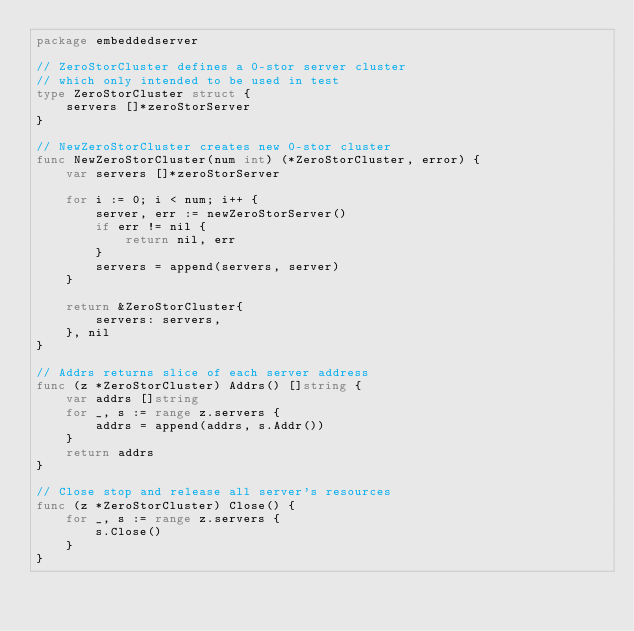<code> <loc_0><loc_0><loc_500><loc_500><_Go_>package embeddedserver

// ZeroStorCluster defines a 0-stor server cluster
// which only intended to be used in test
type ZeroStorCluster struct {
	servers []*zeroStorServer
}

// NewZeroStorCluster creates new 0-stor cluster
func NewZeroStorCluster(num int) (*ZeroStorCluster, error) {
	var servers []*zeroStorServer

	for i := 0; i < num; i++ {
		server, err := newZeroStorServer()
		if err != nil {
			return nil, err
		}
		servers = append(servers, server)
	}

	return &ZeroStorCluster{
		servers: servers,
	}, nil
}

// Addrs returns slice of each server address
func (z *ZeroStorCluster) Addrs() []string {
	var addrs []string
	for _, s := range z.servers {
		addrs = append(addrs, s.Addr())
	}
	return addrs
}

// Close stop and release all server's resources
func (z *ZeroStorCluster) Close() {
	for _, s := range z.servers {
		s.Close()
	}
}
</code> 